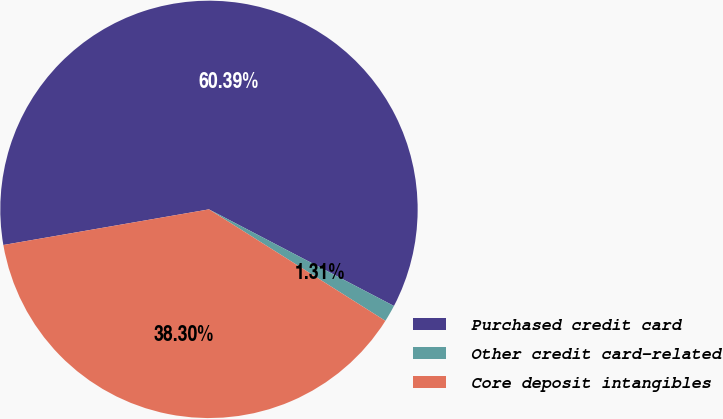<chart> <loc_0><loc_0><loc_500><loc_500><pie_chart><fcel>Purchased credit card<fcel>Other credit card-related<fcel>Core deposit intangibles<nl><fcel>60.39%<fcel>1.31%<fcel>38.3%<nl></chart> 